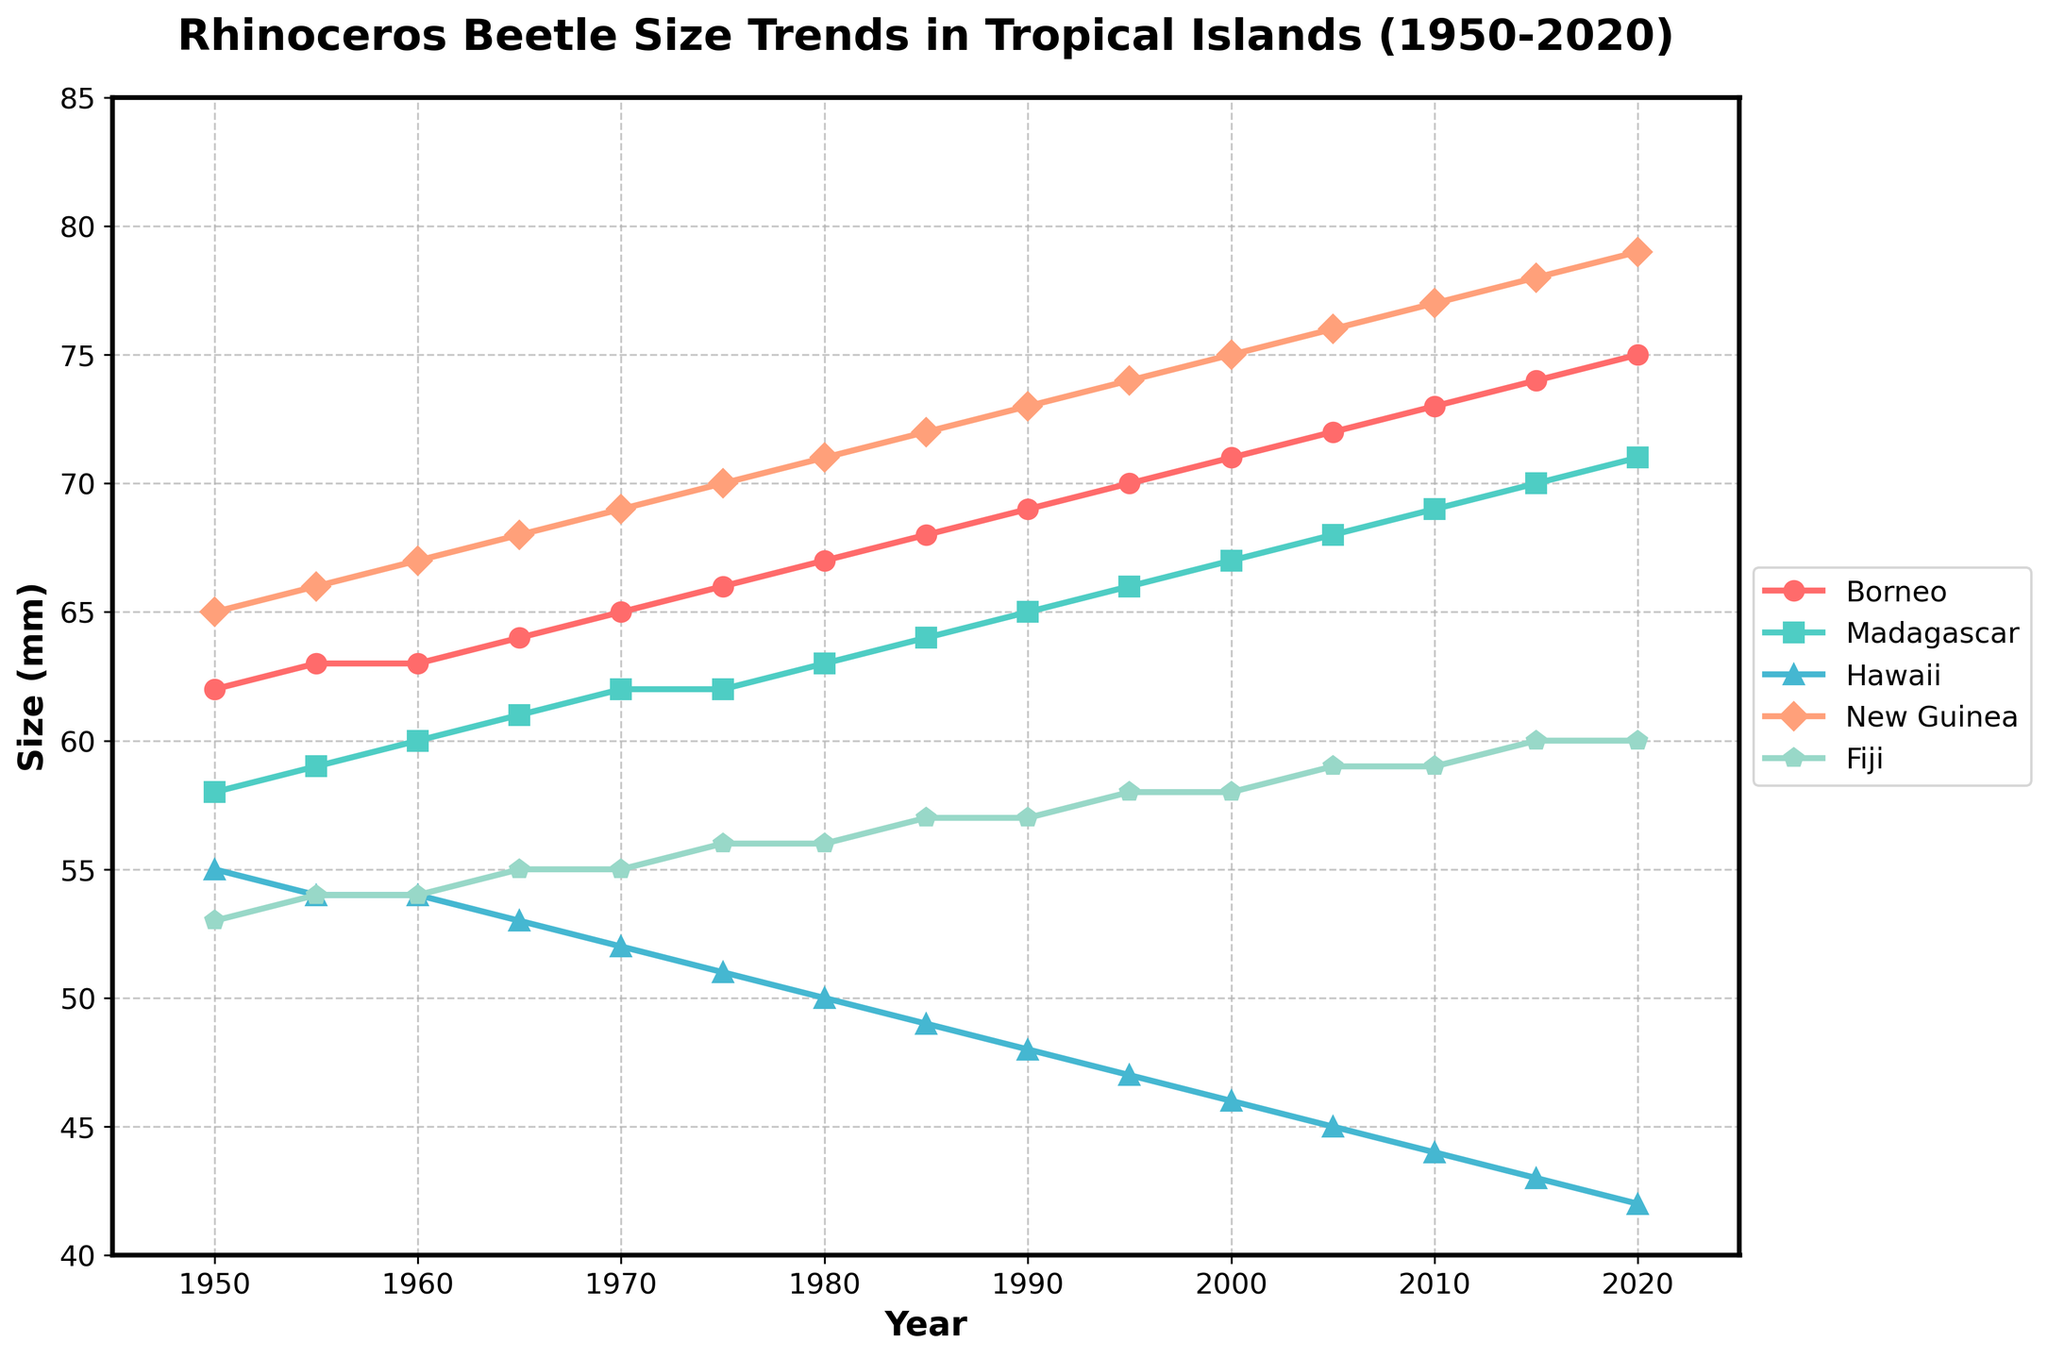Which island saw the most consistent increase in rhinoceros beetle size from 1950 to 2020? By examining the slope of the lines, we see that the line representing 'New Guinea' shows a steady and consistent upward trend in beetle size from 1950 to 2020.
Answer: New Guinea Compare the beetle size trends in Borneo and Hawaii in 2020. Which region had the larger size, and by how much? In 2020, Borneo's beetle size reached 75mm, while Hawaii's was 42mm. The difference is 75 - 42 = 33mm.
Answer: Borneo by 33mm What is the average size of rhinoceros beetles in Madagascar and Fiji in 1980? In 1980, Madagascar's beetle size was 63mm and Fiji's was 56mm. The average size is (63 + 56) / 2 = 59.5mm.
Answer: 59.5mm Which island had the largest decrease in beetle size between 1950 and 2020? Hawaii's beetle size decreased from 55mm in 1950 to 42mm in 2020. The decrease is 55 - 42 = 13mm, which is the largest decrease among all the islands.
Answer: Hawaii By how much did the size of beetles in Fiji increase from 1950 to 2000? In 1950, Fiji's beetle size was 53mm. In 2000, it increased to 58mm. The increase is 58 - 53 = 5mm.
Answer: 5mm Which two islands have the closest beetle sizes in 2015? In 2015, Madagascar's beetle size was 70mm and Fiji's was 60mm. The closest sizes are actually Borneo and New Guinea, with 74mm and 78mm respectively. The difference is 78 - 74 = 4mm.
Answer: Borneo and New Guinea Did any island experience a decrease in beetle size between any two consecutive decades? If so, which island and during what period? Hawaii experienced a decrease in beetle size between almost every consecutive decade. For example, from 1955 (54mm) to 1960 (54mm), and from 1960 (54mm) to 1965 (53mm).
Answer: Hawaii, multiple periods What was the total increase in beetle size in New Guinea from 1950 to 2020? In 1950, New Guinea's beetle size was 65mm. By 2020, it reached 79mm. The total increase is 79 - 65 = 14mm.
Answer: 14mm In which year did Borneo's beetles reach a size of 70mm? From the plot, Borneo's beetles reached a size of 70mm in the year 1995.
Answer: 1995 How does the trend in beetle size in Fiji compare to that in Madagascar over the entire period shown? Both Fiji and Madagascar show a generally increasing trend. However, Fiji's increase is from 53mm to 60mm (7mm increase), while Madagascar's increase is from 58mm to 71mm (13mm increase), indicating Madagascar had a greater overall increase.
Answer: Both increase, Madagascar more 